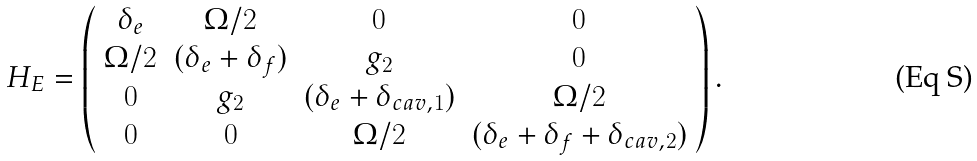Convert formula to latex. <formula><loc_0><loc_0><loc_500><loc_500>H _ { E } = \left ( \begin{array} { c c c c } \delta _ { e } & \Omega / 2 & 0 & 0 \\ \Omega / 2 & ( \delta _ { e } + \delta _ { f } ) & g _ { 2 } & 0 \\ 0 & g _ { 2 } & ( \delta _ { e } + \delta _ { c a v , 1 } ) & \Omega / 2 \\ 0 & 0 & \Omega / 2 & ( \delta _ { e } + \delta _ { f } + \delta _ { c a v , 2 } ) \\ \end{array} \right ) .</formula> 